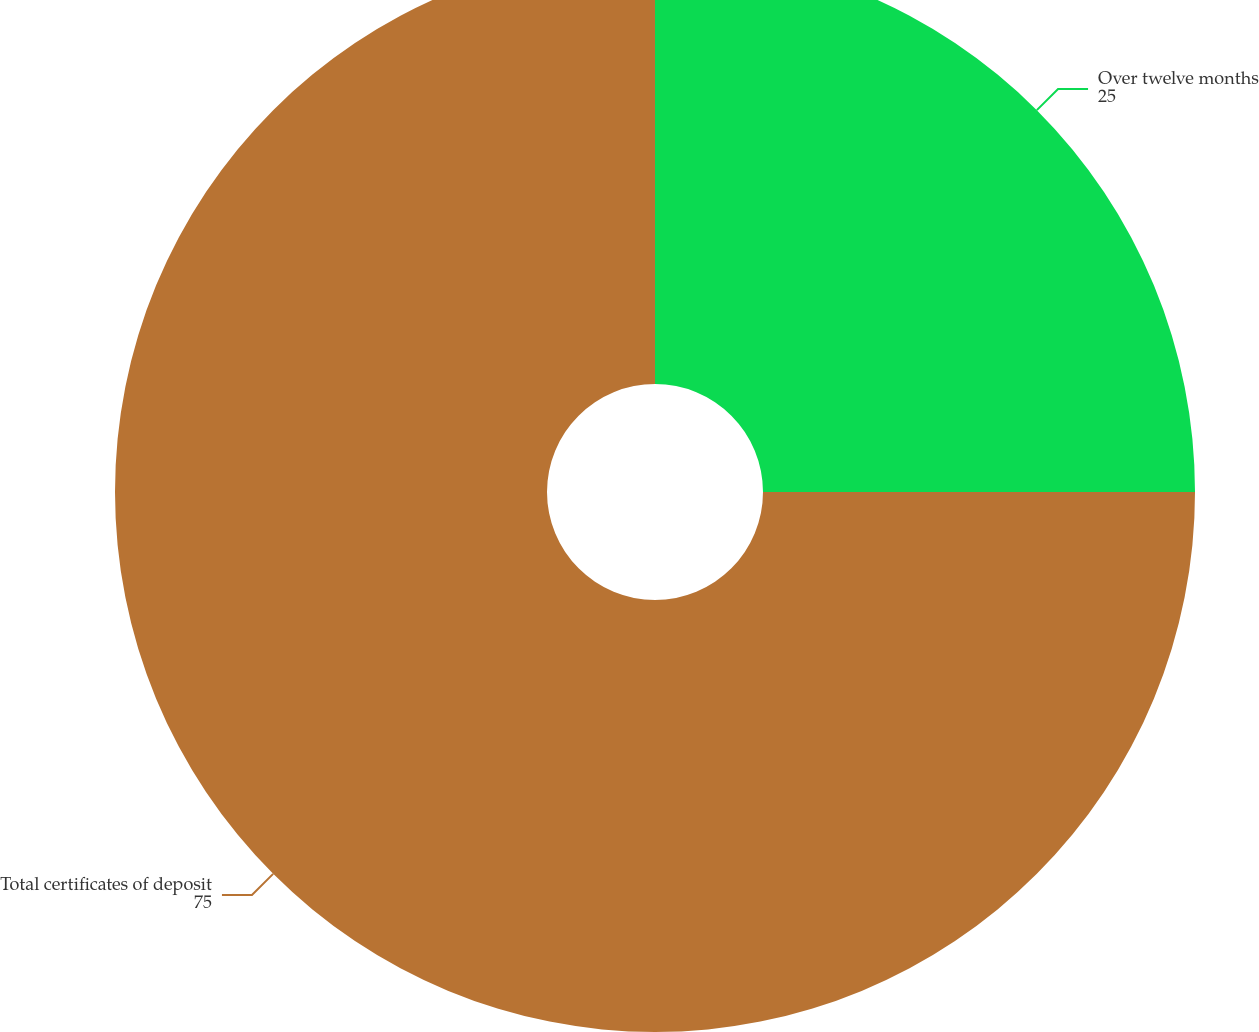Convert chart. <chart><loc_0><loc_0><loc_500><loc_500><pie_chart><fcel>Over twelve months<fcel>Total certificates of deposit<nl><fcel>25.0%<fcel>75.0%<nl></chart> 